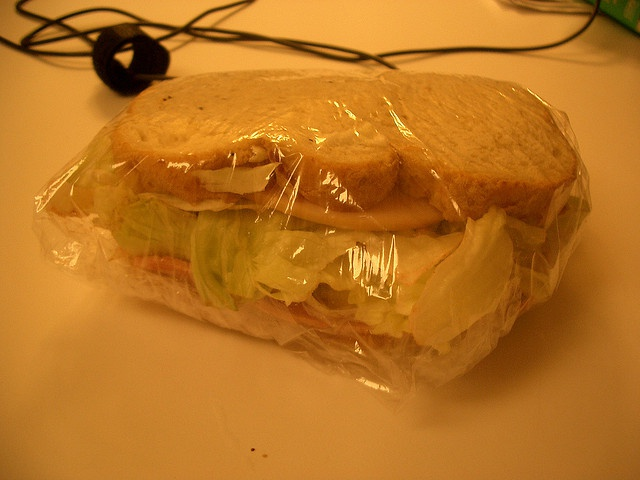Describe the objects in this image and their specific colors. I can see dining table in red, orange, and maroon tones and sandwich in olive, red, orange, and maroon tones in this image. 